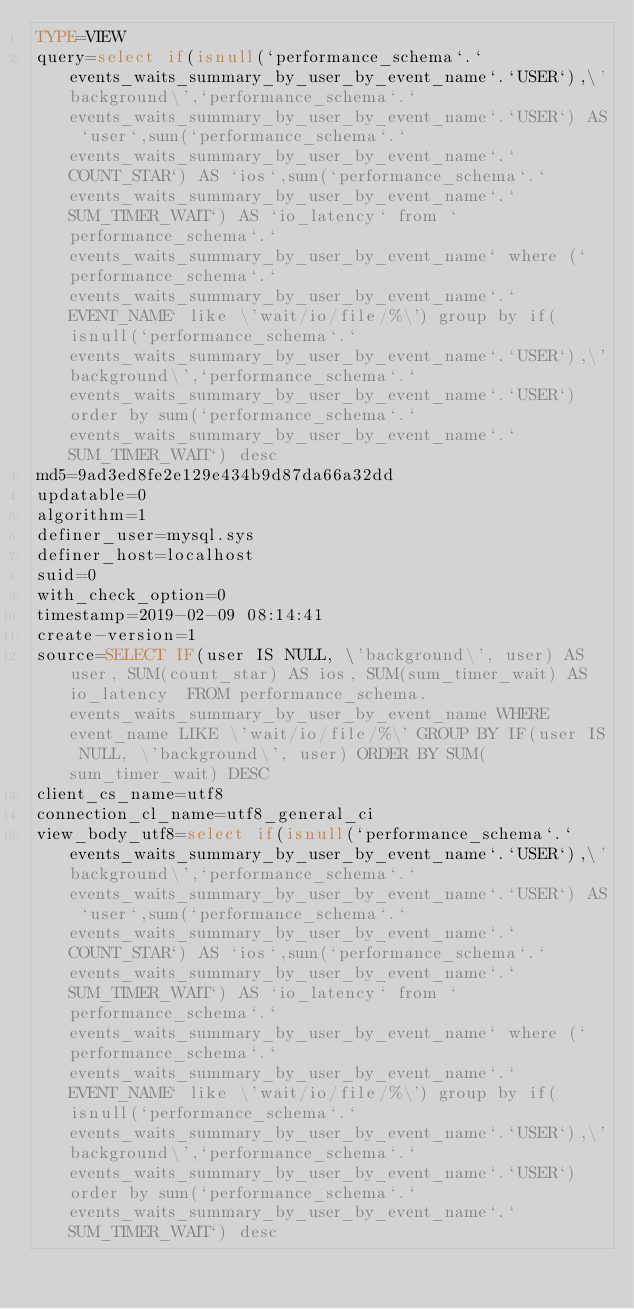Convert code to text. <code><loc_0><loc_0><loc_500><loc_500><_VisualBasic_>TYPE=VIEW
query=select if(isnull(`performance_schema`.`events_waits_summary_by_user_by_event_name`.`USER`),\'background\',`performance_schema`.`events_waits_summary_by_user_by_event_name`.`USER`) AS `user`,sum(`performance_schema`.`events_waits_summary_by_user_by_event_name`.`COUNT_STAR`) AS `ios`,sum(`performance_schema`.`events_waits_summary_by_user_by_event_name`.`SUM_TIMER_WAIT`) AS `io_latency` from `performance_schema`.`events_waits_summary_by_user_by_event_name` where (`performance_schema`.`events_waits_summary_by_user_by_event_name`.`EVENT_NAME` like \'wait/io/file/%\') group by if(isnull(`performance_schema`.`events_waits_summary_by_user_by_event_name`.`USER`),\'background\',`performance_schema`.`events_waits_summary_by_user_by_event_name`.`USER`) order by sum(`performance_schema`.`events_waits_summary_by_user_by_event_name`.`SUM_TIMER_WAIT`) desc
md5=9ad3ed8fe2e129e434b9d87da66a32dd
updatable=0
algorithm=1
definer_user=mysql.sys
definer_host=localhost
suid=0
with_check_option=0
timestamp=2019-02-09 08:14:41
create-version=1
source=SELECT IF(user IS NULL, \'background\', user) AS user, SUM(count_star) AS ios, SUM(sum_timer_wait) AS io_latency  FROM performance_schema.events_waits_summary_by_user_by_event_name WHERE event_name LIKE \'wait/io/file/%\' GROUP BY IF(user IS NULL, \'background\', user) ORDER BY SUM(sum_timer_wait) DESC
client_cs_name=utf8
connection_cl_name=utf8_general_ci
view_body_utf8=select if(isnull(`performance_schema`.`events_waits_summary_by_user_by_event_name`.`USER`),\'background\',`performance_schema`.`events_waits_summary_by_user_by_event_name`.`USER`) AS `user`,sum(`performance_schema`.`events_waits_summary_by_user_by_event_name`.`COUNT_STAR`) AS `ios`,sum(`performance_schema`.`events_waits_summary_by_user_by_event_name`.`SUM_TIMER_WAIT`) AS `io_latency` from `performance_schema`.`events_waits_summary_by_user_by_event_name` where (`performance_schema`.`events_waits_summary_by_user_by_event_name`.`EVENT_NAME` like \'wait/io/file/%\') group by if(isnull(`performance_schema`.`events_waits_summary_by_user_by_event_name`.`USER`),\'background\',`performance_schema`.`events_waits_summary_by_user_by_event_name`.`USER`) order by sum(`performance_schema`.`events_waits_summary_by_user_by_event_name`.`SUM_TIMER_WAIT`) desc
</code> 